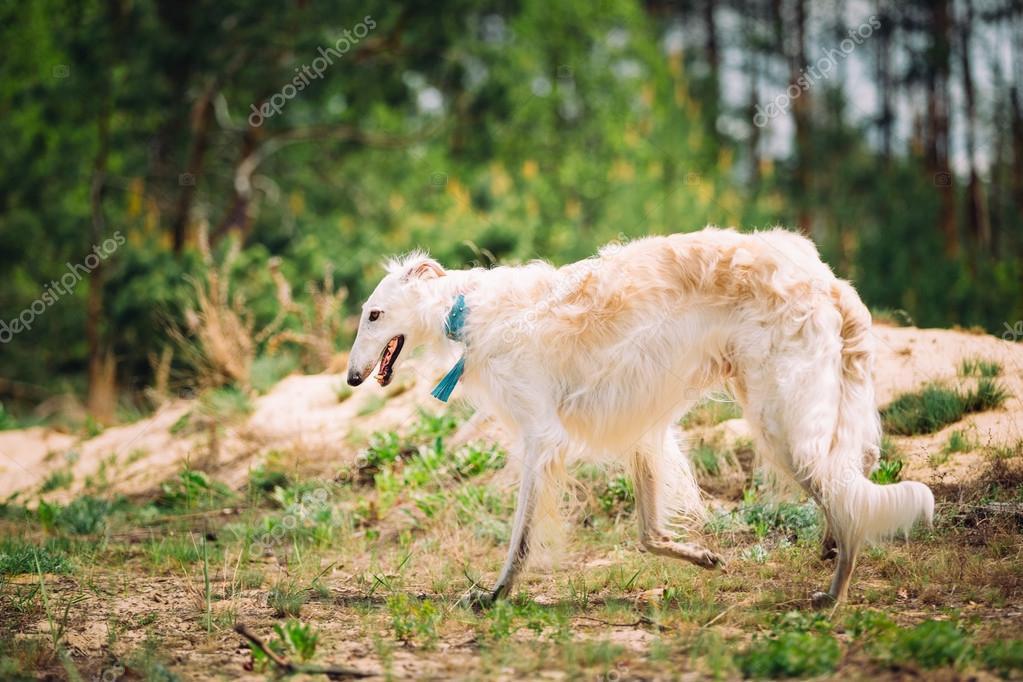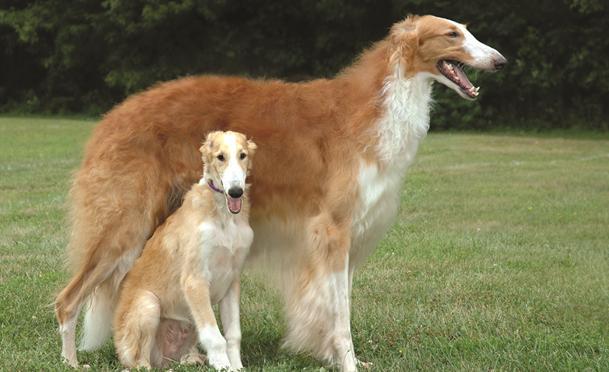The first image is the image on the left, the second image is the image on the right. Analyze the images presented: Is the assertion "There is one image of two dogs that are actively playing together outside." valid? Answer yes or no. No. The first image is the image on the left, the second image is the image on the right. Assess this claim about the two images: "One images has two dogs fighting each other.". Correct or not? Answer yes or no. No. 